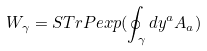Convert formula to latex. <formula><loc_0><loc_0><loc_500><loc_500>W _ { \gamma } = S T r P e x p ( \oint _ { \gamma } d y ^ { a } A _ { a } )</formula> 